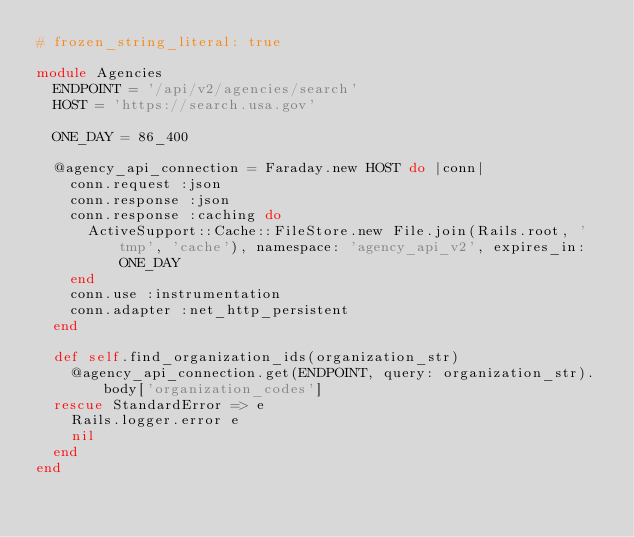Convert code to text. <code><loc_0><loc_0><loc_500><loc_500><_Ruby_># frozen_string_literal: true

module Agencies
  ENDPOINT = '/api/v2/agencies/search'
  HOST = 'https://search.usa.gov'

  ONE_DAY = 86_400

  @agency_api_connection = Faraday.new HOST do |conn|
    conn.request :json
    conn.response :json
    conn.response :caching do
      ActiveSupport::Cache::FileStore.new File.join(Rails.root, 'tmp', 'cache'), namespace: 'agency_api_v2', expires_in: ONE_DAY
    end
    conn.use :instrumentation
    conn.adapter :net_http_persistent
  end

  def self.find_organization_ids(organization_str)
    @agency_api_connection.get(ENDPOINT, query: organization_str).body['organization_codes']
  rescue StandardError => e
    Rails.logger.error e
    nil
  end
end
</code> 